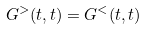Convert formula to latex. <formula><loc_0><loc_0><loc_500><loc_500>G ^ { > } ( t , t ) = G ^ { < } ( t , t )</formula> 